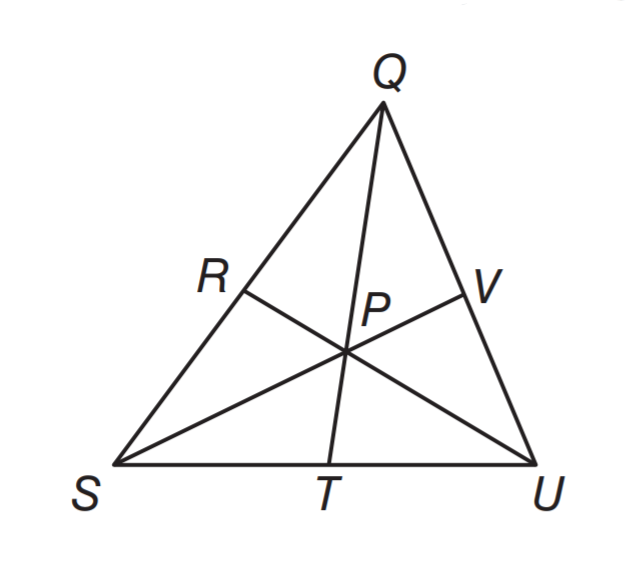Answer the mathemtical geometry problem and directly provide the correct option letter.
Question: P is the centroid of triangle Q U S. If Q P = 14 centimeters, what is the length of Q T?
Choices: A: 7 B: 12 C: 18 D: 21 D 